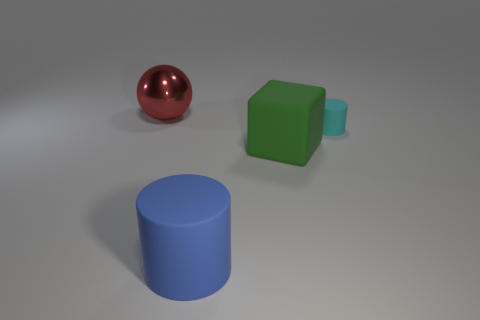Is there any other thing that has the same size as the cyan cylinder?
Provide a short and direct response. No. Is there anything else that is the same shape as the large red metal object?
Provide a succinct answer. No. How many other objects are there of the same material as the big red ball?
Offer a terse response. 0. There is a green object; is its size the same as the cylinder behind the big matte cylinder?
Keep it short and to the point. No. Are there fewer big spheres that are behind the cube than rubber objects in front of the cyan cylinder?
Your answer should be very brief. Yes. What size is the cylinder behind the large rubber cylinder?
Keep it short and to the point. Small. Does the green matte object have the same size as the cyan thing?
Offer a terse response. No. What number of objects are both on the left side of the small cyan cylinder and on the right side of the large red ball?
Keep it short and to the point. 2. How many red things are either shiny things or large cylinders?
Your answer should be very brief. 1. What number of rubber objects are either big yellow blocks or large things?
Make the answer very short. 2. 